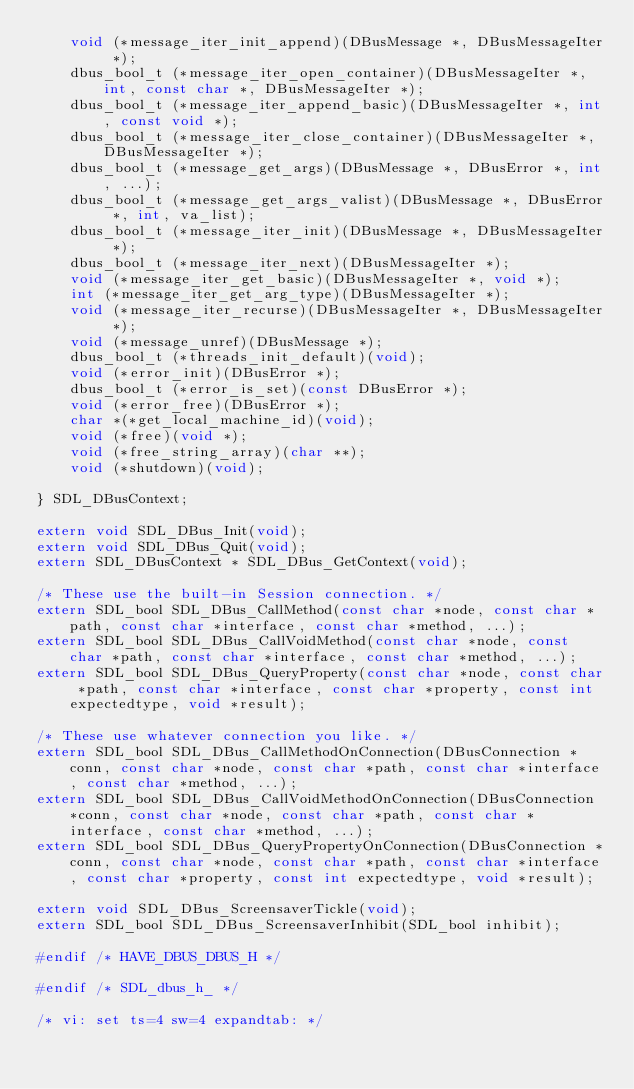<code> <loc_0><loc_0><loc_500><loc_500><_C_>    void (*message_iter_init_append)(DBusMessage *, DBusMessageIter *);
    dbus_bool_t (*message_iter_open_container)(DBusMessageIter *, int, const char *, DBusMessageIter *);
    dbus_bool_t (*message_iter_append_basic)(DBusMessageIter *, int, const void *);
    dbus_bool_t (*message_iter_close_container)(DBusMessageIter *, DBusMessageIter *);
    dbus_bool_t (*message_get_args)(DBusMessage *, DBusError *, int, ...);
    dbus_bool_t (*message_get_args_valist)(DBusMessage *, DBusError *, int, va_list);
    dbus_bool_t (*message_iter_init)(DBusMessage *, DBusMessageIter *);
    dbus_bool_t (*message_iter_next)(DBusMessageIter *);
    void (*message_iter_get_basic)(DBusMessageIter *, void *);
    int (*message_iter_get_arg_type)(DBusMessageIter *);
    void (*message_iter_recurse)(DBusMessageIter *, DBusMessageIter *); 
    void (*message_unref)(DBusMessage *);
    dbus_bool_t (*threads_init_default)(void);
    void (*error_init)(DBusError *);
    dbus_bool_t (*error_is_set)(const DBusError *);
    void (*error_free)(DBusError *);
    char *(*get_local_machine_id)(void);
    void (*free)(void *);
    void (*free_string_array)(char **);
    void (*shutdown)(void);

} SDL_DBusContext;

extern void SDL_DBus_Init(void);
extern void SDL_DBus_Quit(void);
extern SDL_DBusContext * SDL_DBus_GetContext(void);

/* These use the built-in Session connection. */
extern SDL_bool SDL_DBus_CallMethod(const char *node, const char *path, const char *interface, const char *method, ...);
extern SDL_bool SDL_DBus_CallVoidMethod(const char *node, const char *path, const char *interface, const char *method, ...);
extern SDL_bool SDL_DBus_QueryProperty(const char *node, const char *path, const char *interface, const char *property, const int expectedtype, void *result);

/* These use whatever connection you like. */
extern SDL_bool SDL_DBus_CallMethodOnConnection(DBusConnection *conn, const char *node, const char *path, const char *interface, const char *method, ...);
extern SDL_bool SDL_DBus_CallVoidMethodOnConnection(DBusConnection *conn, const char *node, const char *path, const char *interface, const char *method, ...);
extern SDL_bool SDL_DBus_QueryPropertyOnConnection(DBusConnection *conn, const char *node, const char *path, const char *interface, const char *property, const int expectedtype, void *result);

extern void SDL_DBus_ScreensaverTickle(void);
extern SDL_bool SDL_DBus_ScreensaverInhibit(SDL_bool inhibit);

#endif /* HAVE_DBUS_DBUS_H */

#endif /* SDL_dbus_h_ */

/* vi: set ts=4 sw=4 expandtab: */
</code> 